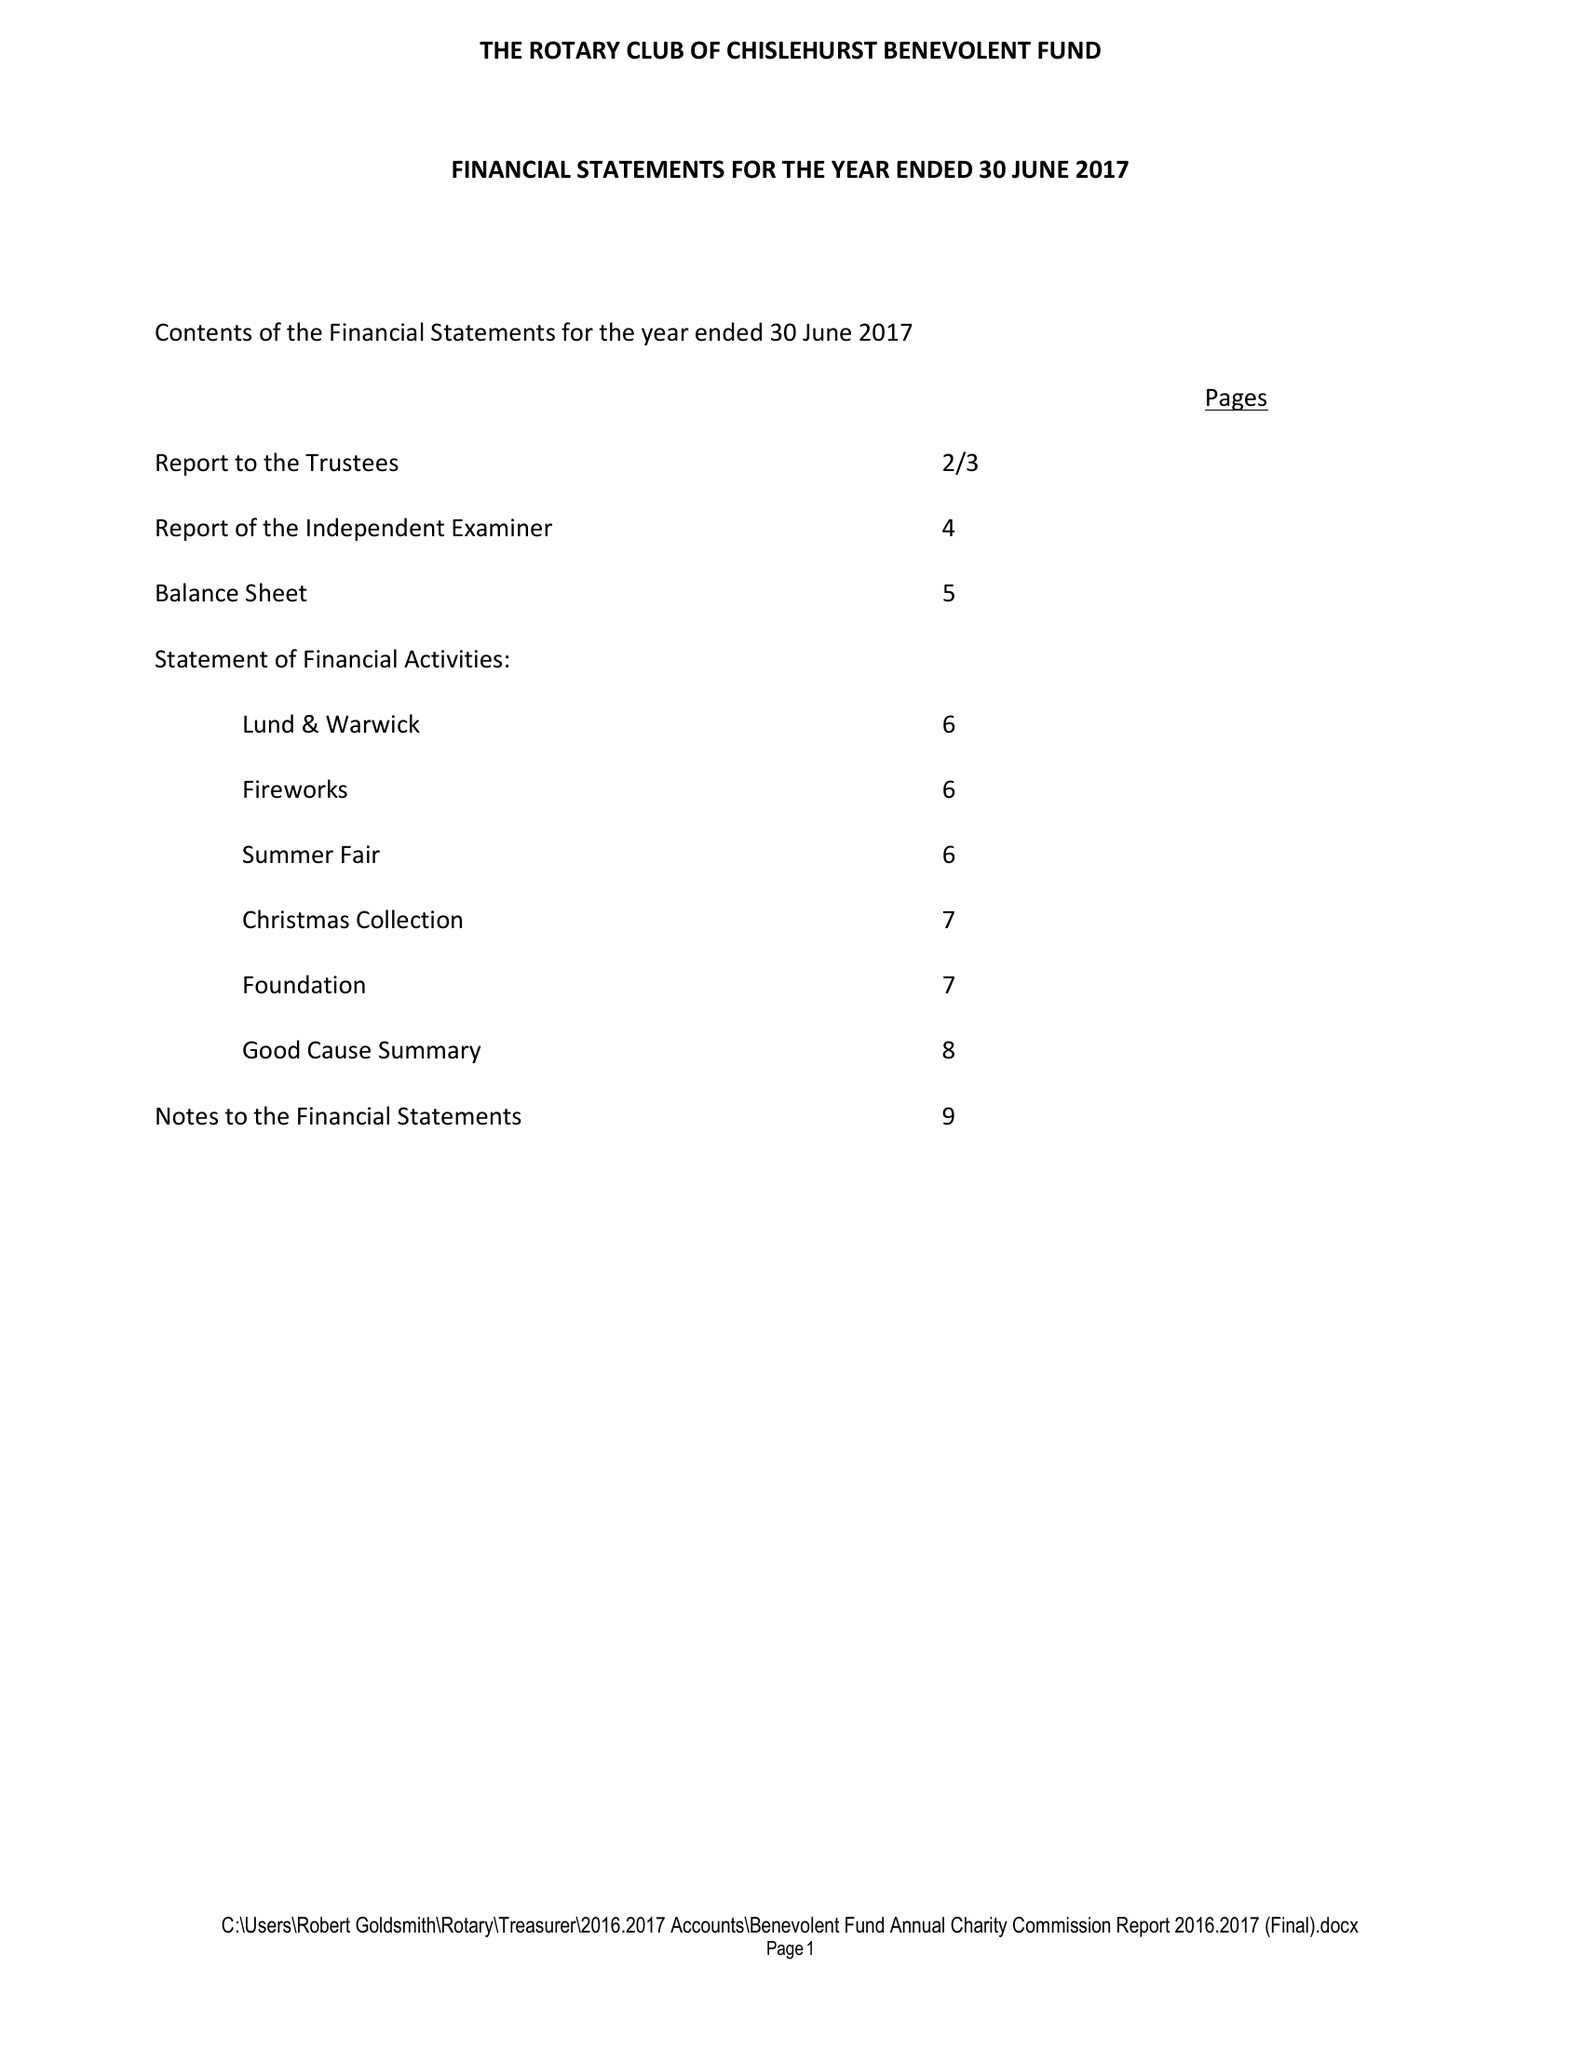What is the value for the address__postcode?
Answer the question using a single word or phrase. BR6 7RS 